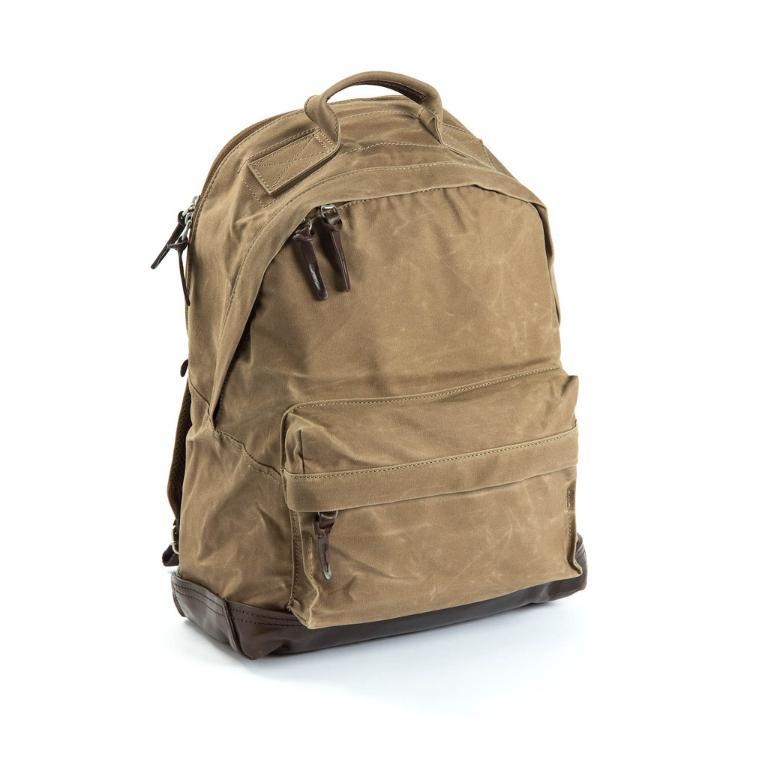What color is the bag in the image? The bag in the image is brown. What color is the background of the image? The background of the image is white. Can you tell me how many islands are visible in the image? There are no islands present in the image. What type of joke is being told by the fork in the image? There is no fork or joke present in the image. 